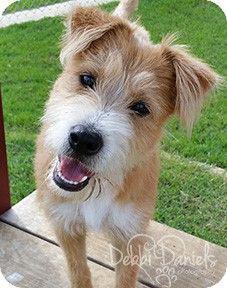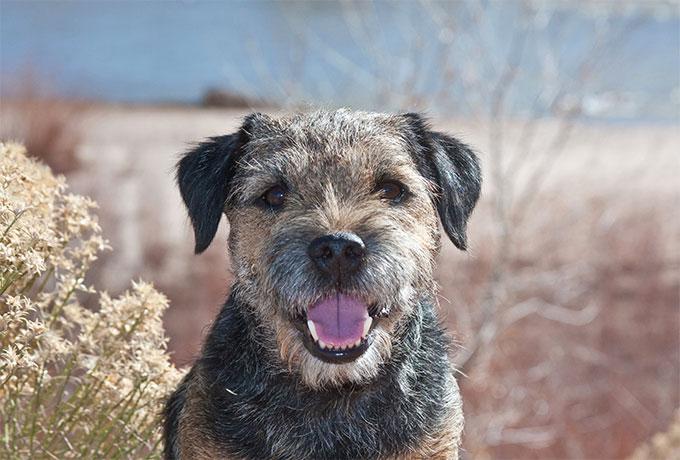The first image is the image on the left, the second image is the image on the right. For the images displayed, is the sentence "There is some green grass in the background of every image." factually correct? Answer yes or no. No. The first image is the image on the left, the second image is the image on the right. Considering the images on both sides, is "The dog on the right has a blue collar" valid? Answer yes or no. No. 